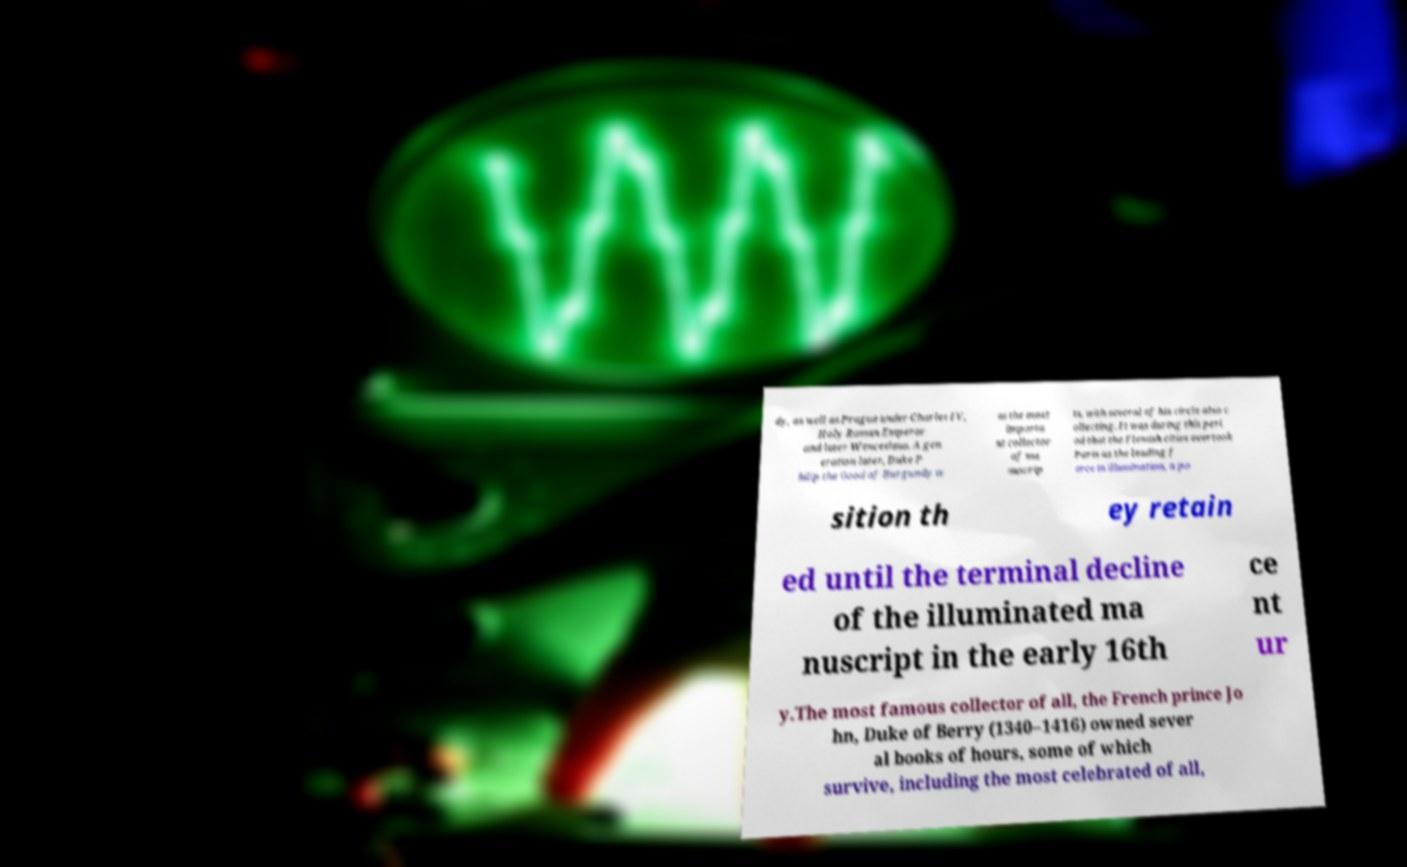There's text embedded in this image that I need extracted. Can you transcribe it verbatim? dy, as well as Prague under Charles IV, Holy Roman Emperor and later Wenceslaus. A gen eration later, Duke P hilip the Good of Burgundy w as the most importa nt collector of ma nuscrip ts, with several of his circle also c ollecting. It was during this peri od that the Flemish cities overtook Paris as the leading f orce in illumination, a po sition th ey retain ed until the terminal decline of the illuminated ma nuscript in the early 16th ce nt ur y.The most famous collector of all, the French prince Jo hn, Duke of Berry (1340–1416) owned sever al books of hours, some of which survive, including the most celebrated of all, 